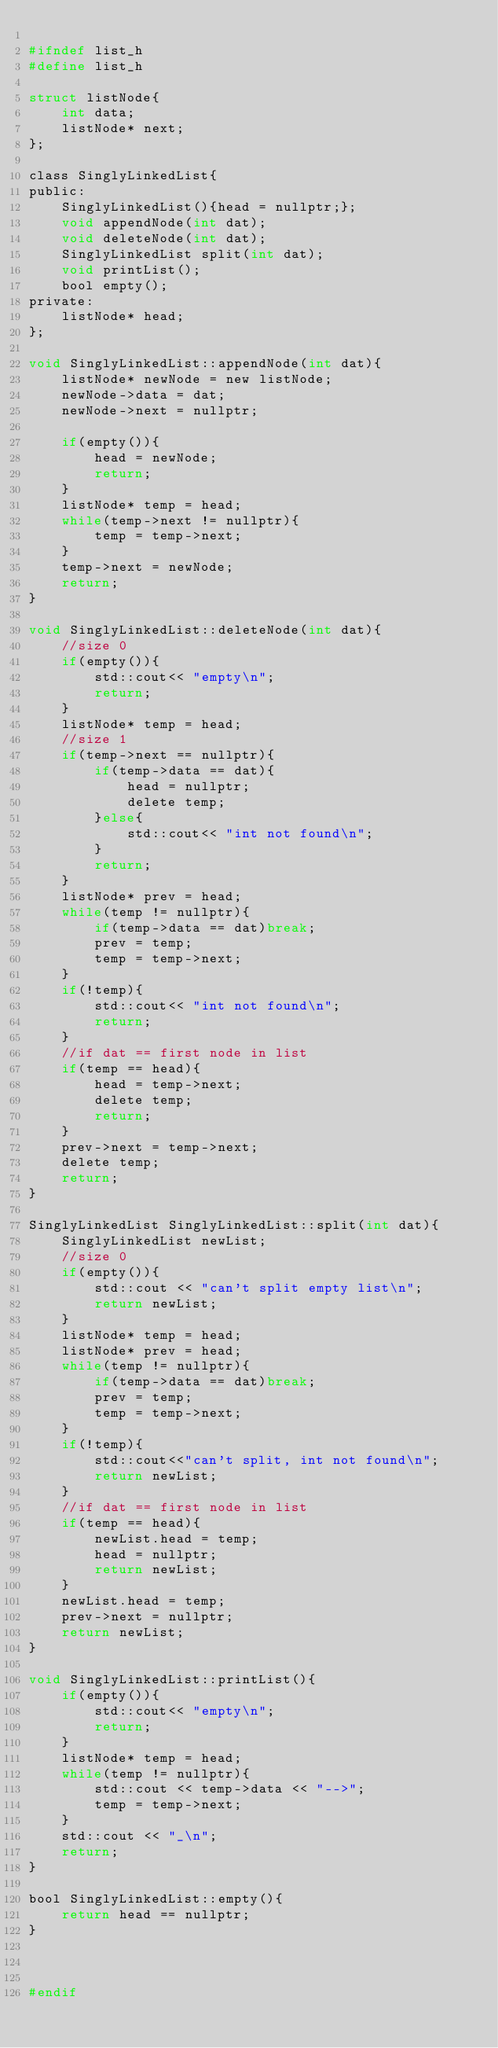<code> <loc_0><loc_0><loc_500><loc_500><_C_>
#ifndef list_h
#define list_h

struct listNode{
    int data;
    listNode* next;
};

class SinglyLinkedList{
public:
    SinglyLinkedList(){head = nullptr;};
    void appendNode(int dat);
    void deleteNode(int dat);
    SinglyLinkedList split(int dat);
    void printList();
    bool empty();
private:
    listNode* head;
};

void SinglyLinkedList::appendNode(int dat){
    listNode* newNode = new listNode;
    newNode->data = dat;
    newNode->next = nullptr;
    
    if(empty()){
        head = newNode;
        return;
    }
    listNode* temp = head;
    while(temp->next != nullptr){
        temp = temp->next;
    }
    temp->next = newNode;
    return;
}

void SinglyLinkedList::deleteNode(int dat){
    //size 0
    if(empty()){
        std::cout<< "empty\n";
        return;
    }
    listNode* temp = head;
    //size 1
    if(temp->next == nullptr){
        if(temp->data == dat){
            head = nullptr;
            delete temp;
        }else{
            std::cout<< "int not found\n";
        }
        return;
    }
    listNode* prev = head;
    while(temp != nullptr){
        if(temp->data == dat)break;
        prev = temp;
        temp = temp->next;
    }
    if(!temp){
        std::cout<< "int not found\n";
        return;
    }
    //if dat == first node in list
    if(temp == head){
        head = temp->next;
        delete temp;
        return;
    }
    prev->next = temp->next;
    delete temp;
    return;
}

SinglyLinkedList SinglyLinkedList::split(int dat){
    SinglyLinkedList newList;
    //size 0
    if(empty()){
        std::cout << "can't split empty list\n";
        return newList;
    }
    listNode* temp = head;
    listNode* prev = head;
    while(temp != nullptr){
        if(temp->data == dat)break;
        prev = temp;
        temp = temp->next;
    }
    if(!temp){
        std::cout<<"can't split, int not found\n";
        return newList;
    }
    //if dat == first node in list
    if(temp == head){
        newList.head = temp;
        head = nullptr;
        return newList;
    }
    newList.head = temp;
    prev->next = nullptr;
    return newList;
}

void SinglyLinkedList::printList(){
    if(empty()){
        std::cout<< "empty\n";
        return;
    }
    listNode* temp = head;
    while(temp != nullptr){
        std::cout << temp->data << "-->";
        temp = temp->next;
    }
    std::cout << "_\n";
    return;
}

bool SinglyLinkedList::empty(){
    return head == nullptr;
}



#endif
</code> 